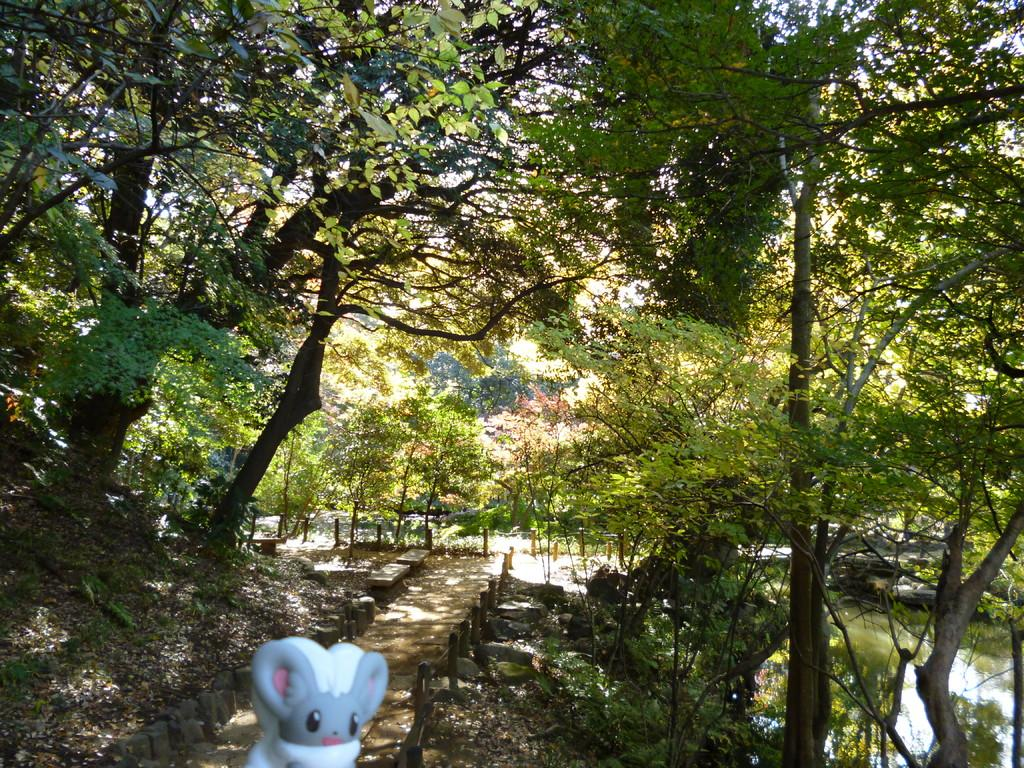What is located in the foreground of the image? There is a toy in the foreground of the image. What type of location is depicted in the image? There is an alley in the image. What type of vegetation is present in the image? Plants and trees are present in the image. What natural feature can be seen in the image? There is a water body in the image. What is visible in the background of the image? Trees and rocks are visible in the background of the image, along with other unspecified items. What type of stocking is hanging from the tree in the image? There is no stocking hanging from a tree in the image. What is the shape of the heart visible in the image? There is no heart present in the image. 